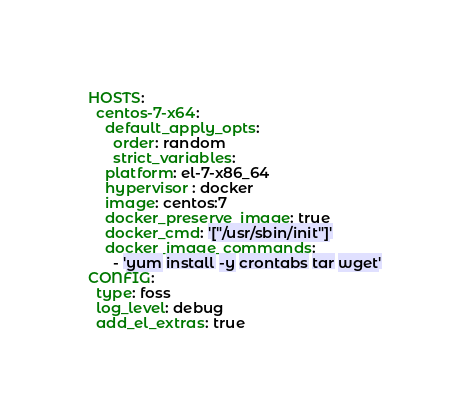Convert code to text. <code><loc_0><loc_0><loc_500><loc_500><_YAML_>HOSTS:
  centos-7-x64:
    default_apply_opts:
      order: random
      strict_variables:
    platform: el-7-x86_64
    hypervisor : docker
    image: centos:7
    docker_preserve_image: true
    docker_cmd: '["/usr/sbin/init"]'
    docker_image_commands:
      - 'yum install -y crontabs tar wget'
CONFIG:
  type: foss
  log_level: debug
  add_el_extras: true
</code> 